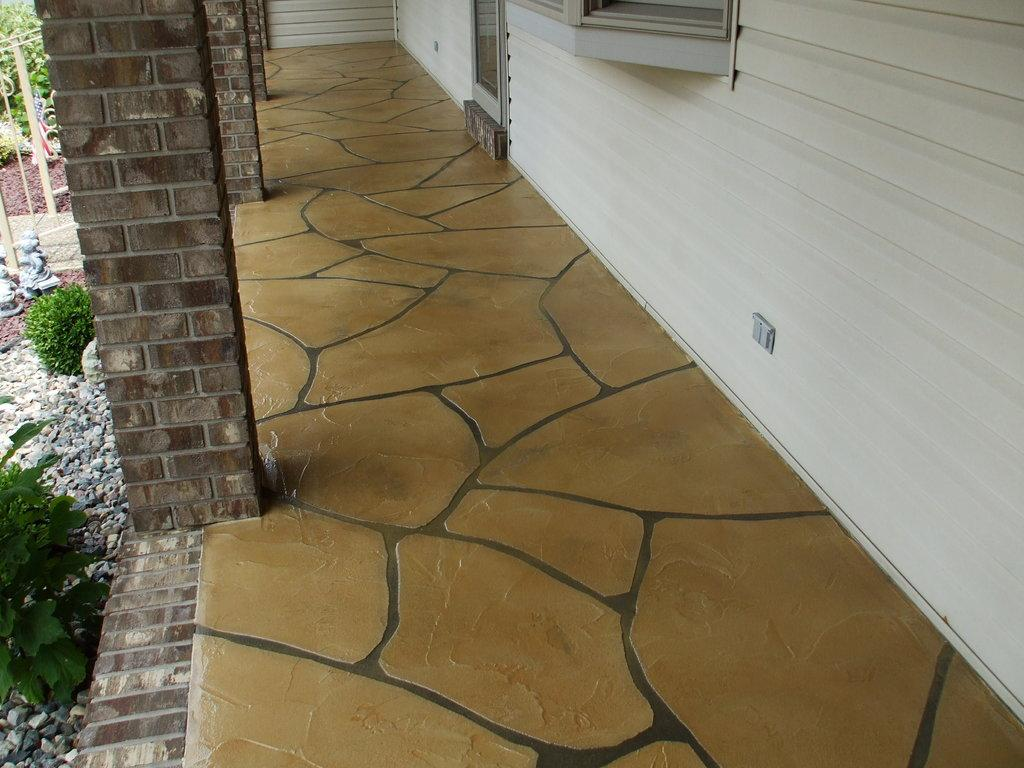What type of structure can be seen in the image? There is a wall in the image. What is the surface beneath the wall? There is a floor in the image. Are there any architectural elements supporting the wall? Yes, there are pillars in the image. What type of material is present in the image? There are stones in the image. What type of vegetation is present in the image? There are plants in the image. Can you see a face carved into one of the stones in the image? There is no face carved into any of the stones in the image. Is there a letter lying on the floor in the image? There is no letter present on the floor in the image. 